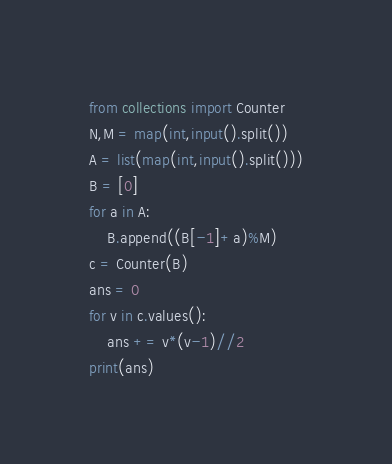Convert code to text. <code><loc_0><loc_0><loc_500><loc_500><_Python_>from collections import Counter
N,M = map(int,input().split())
A = list(map(int,input().split()))
B = [0]
for a in A:
    B.append((B[-1]+a)%M)
c = Counter(B)
ans = 0
for v in c.values():
    ans += v*(v-1)//2
print(ans)
</code> 